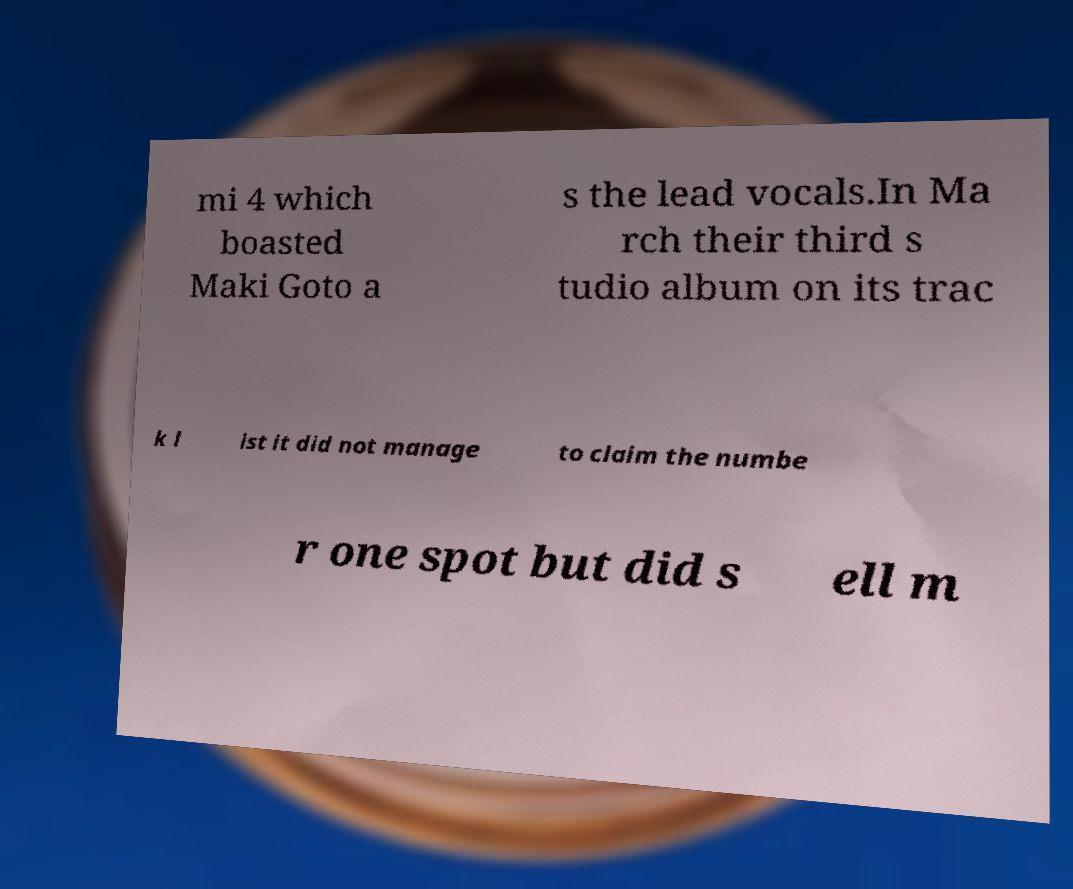There's text embedded in this image that I need extracted. Can you transcribe it verbatim? mi 4 which boasted Maki Goto a s the lead vocals.In Ma rch their third s tudio album on its trac k l ist it did not manage to claim the numbe r one spot but did s ell m 